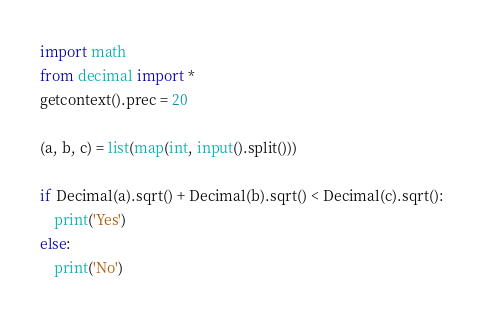<code> <loc_0><loc_0><loc_500><loc_500><_Python_>import math
from decimal import *
getcontext().prec = 20

(a, b, c) = list(map(int, input().split()))

if Decimal(a).sqrt() + Decimal(b).sqrt() < Decimal(c).sqrt():
    print('Yes')
else:
    print('No')</code> 